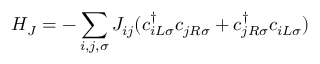<formula> <loc_0><loc_0><loc_500><loc_500>H _ { J } = - \sum _ { i , j , \sigma } J _ { i j } ( c _ { i L \sigma } ^ { \dagger } c _ { j R \sigma } + c _ { j R \sigma } ^ { \dagger } c _ { i L \sigma } )</formula> 